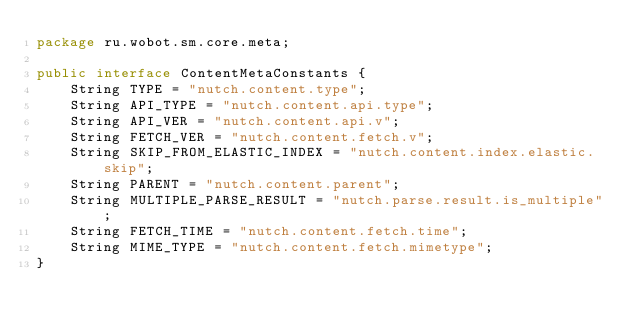<code> <loc_0><loc_0><loc_500><loc_500><_Java_>package ru.wobot.sm.core.meta;

public interface ContentMetaConstants {
    String TYPE = "nutch.content.type";
    String API_TYPE = "nutch.content.api.type";
    String API_VER = "nutch.content.api.v";
    String FETCH_VER = "nutch.content.fetch.v";
    String SKIP_FROM_ELASTIC_INDEX = "nutch.content.index.elastic.skip";
    String PARENT = "nutch.content.parent";
    String MULTIPLE_PARSE_RESULT = "nutch.parse.result.is_multiple";
    String FETCH_TIME = "nutch.content.fetch.time";
    String MIME_TYPE = "nutch.content.fetch.mimetype";
}
</code> 